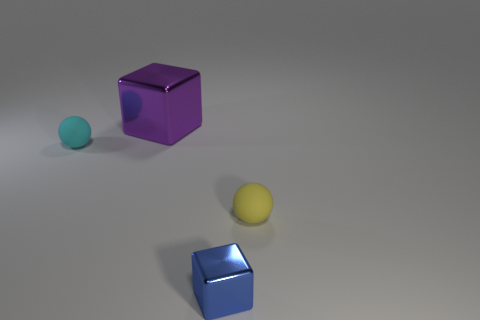Are there the same number of cyan rubber balls behind the blue shiny thing and tiny yellow objects in front of the purple metallic thing?
Offer a very short reply. Yes. What is the yellow ball made of?
Your answer should be compact. Rubber. The other rubber thing that is the same size as the cyan matte thing is what color?
Provide a succinct answer. Yellow. Are there any purple metal objects that are behind the matte ball that is to the left of the tiny yellow matte object?
Make the answer very short. Yes. How many cylinders are tiny red rubber objects or small cyan objects?
Offer a very short reply. 0. There is a cube behind the tiny object in front of the tiny ball that is to the right of the small cyan thing; how big is it?
Offer a terse response. Large. There is a yellow object; are there any tiny rubber balls left of it?
Make the answer very short. Yes. What number of things are shiny things that are in front of the yellow rubber object or big cyan matte cubes?
Ensure brevity in your answer.  1. What is the size of the thing that is made of the same material as the tiny blue cube?
Make the answer very short. Large. There is a blue thing; is it the same size as the metallic thing that is to the left of the tiny metallic object?
Offer a very short reply. No. 